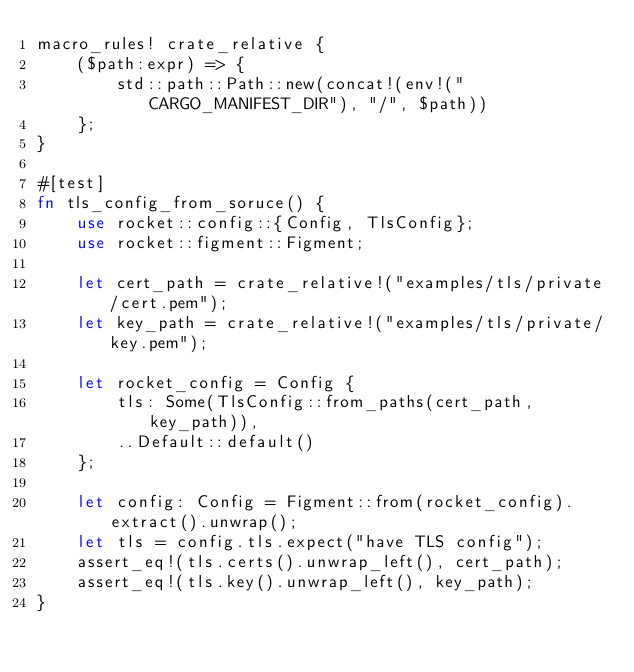Convert code to text. <code><loc_0><loc_0><loc_500><loc_500><_Rust_>macro_rules! crate_relative {
    ($path:expr) => {
        std::path::Path::new(concat!(env!("CARGO_MANIFEST_DIR"), "/", $path))
    };
}

#[test]
fn tls_config_from_soruce() {
    use rocket::config::{Config, TlsConfig};
    use rocket::figment::Figment;

    let cert_path = crate_relative!("examples/tls/private/cert.pem");
    let key_path = crate_relative!("examples/tls/private/key.pem");

    let rocket_config = Config {
        tls: Some(TlsConfig::from_paths(cert_path, key_path)),
        ..Default::default()
    };

    let config: Config = Figment::from(rocket_config).extract().unwrap();
    let tls = config.tls.expect("have TLS config");
    assert_eq!(tls.certs().unwrap_left(), cert_path);
    assert_eq!(tls.key().unwrap_left(), key_path);
}
</code> 